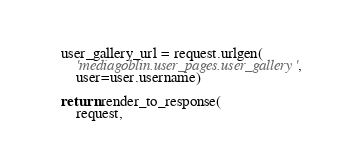<code> <loc_0><loc_0><loc_500><loc_500><_Python_>
    user_gallery_url = request.urlgen(
        'mediagoblin.user_pages.user_gallery',
        user=user.username)

    return render_to_response(
        request,</code> 